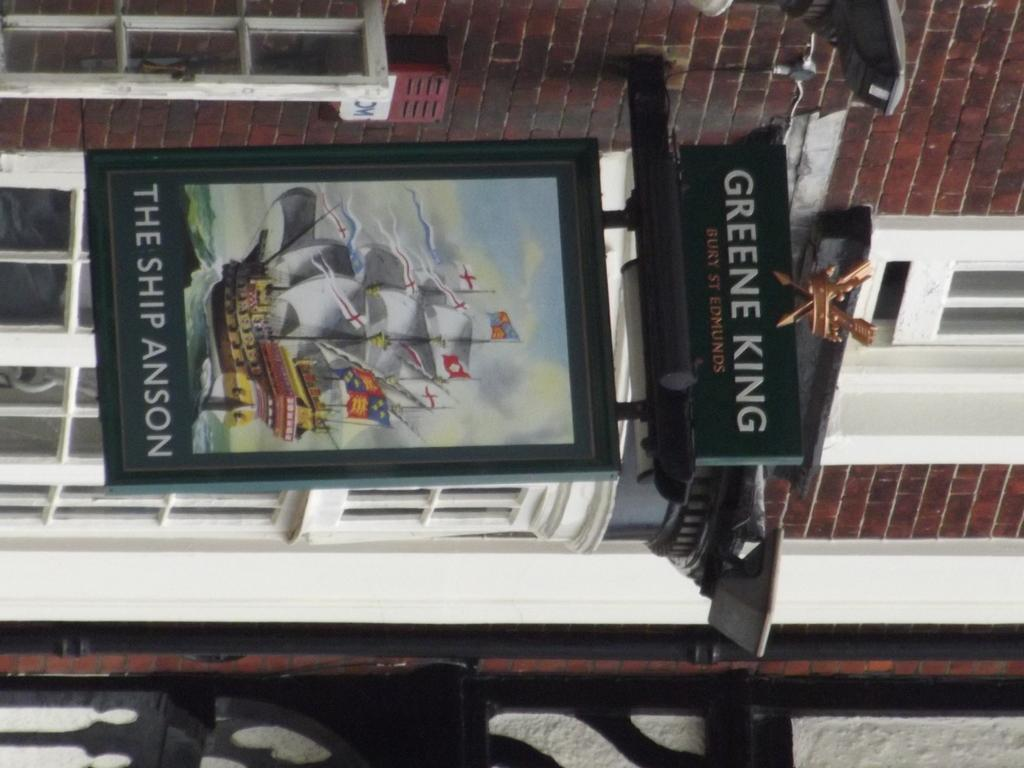What type of structure is visible in the image? There is a building in the image. What feature can be observed on the building? The building has glass windows. What is located near the building in the image? There is a board in the image. What is depicted on the board? The board contains an image of a ship. Are there any words or letters on the board? Yes, there is text on the board. How many boys are playing with a cap on the ship in the image? There are no boys or caps present on the ship in the image, as the board only contains an image of a ship. 